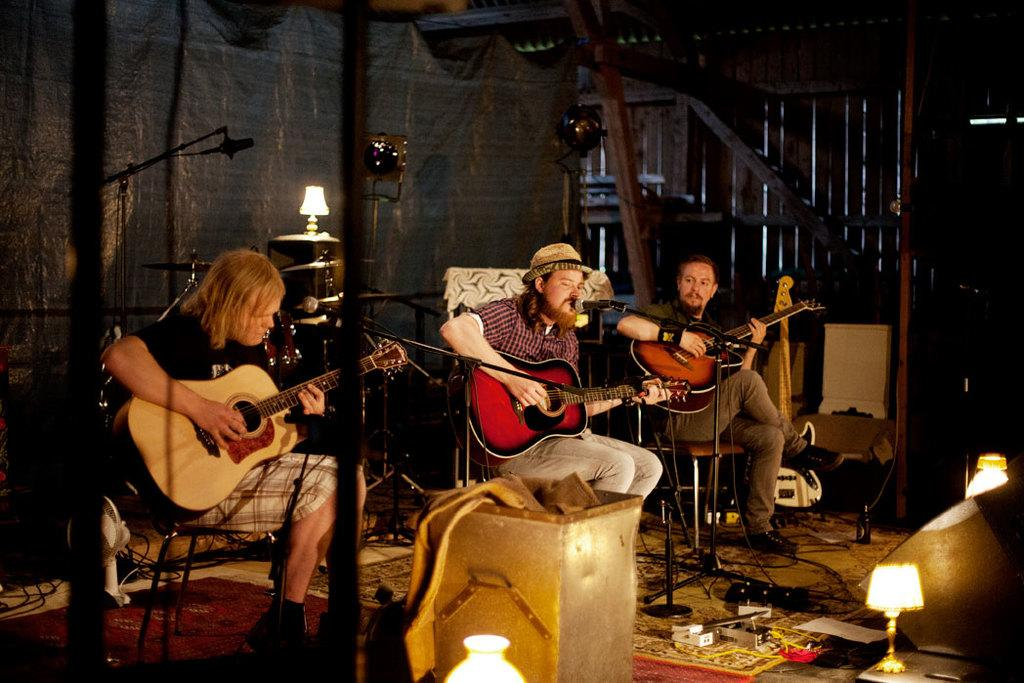What objects can be seen in the background of the image? There is a microphone and a lamp in the background of the image. How many men are present in the image? There are three men in the image. What are the men doing in the image? The men are sitting on chairs and playing guitars. What type of flooring is visible in the image? There is a floor carpet in the image. What type of hen can be seen walking on the carpet in the image? There is no hen present in the image; it features three men playing guitars and a carpeted floor. What type of root is visible on the microphone in the image? There is no root visible on the microphone in the image; it is a standalone object in the background. 